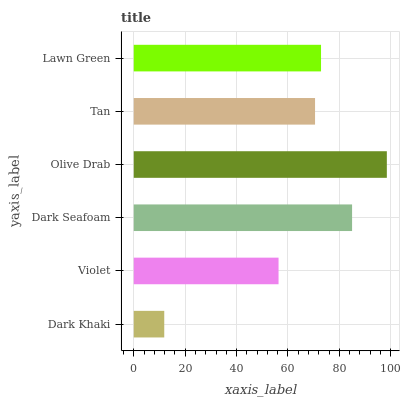Is Dark Khaki the minimum?
Answer yes or no. Yes. Is Olive Drab the maximum?
Answer yes or no. Yes. Is Violet the minimum?
Answer yes or no. No. Is Violet the maximum?
Answer yes or no. No. Is Violet greater than Dark Khaki?
Answer yes or no. Yes. Is Dark Khaki less than Violet?
Answer yes or no. Yes. Is Dark Khaki greater than Violet?
Answer yes or no. No. Is Violet less than Dark Khaki?
Answer yes or no. No. Is Lawn Green the high median?
Answer yes or no. Yes. Is Tan the low median?
Answer yes or no. Yes. Is Tan the high median?
Answer yes or no. No. Is Violet the low median?
Answer yes or no. No. 